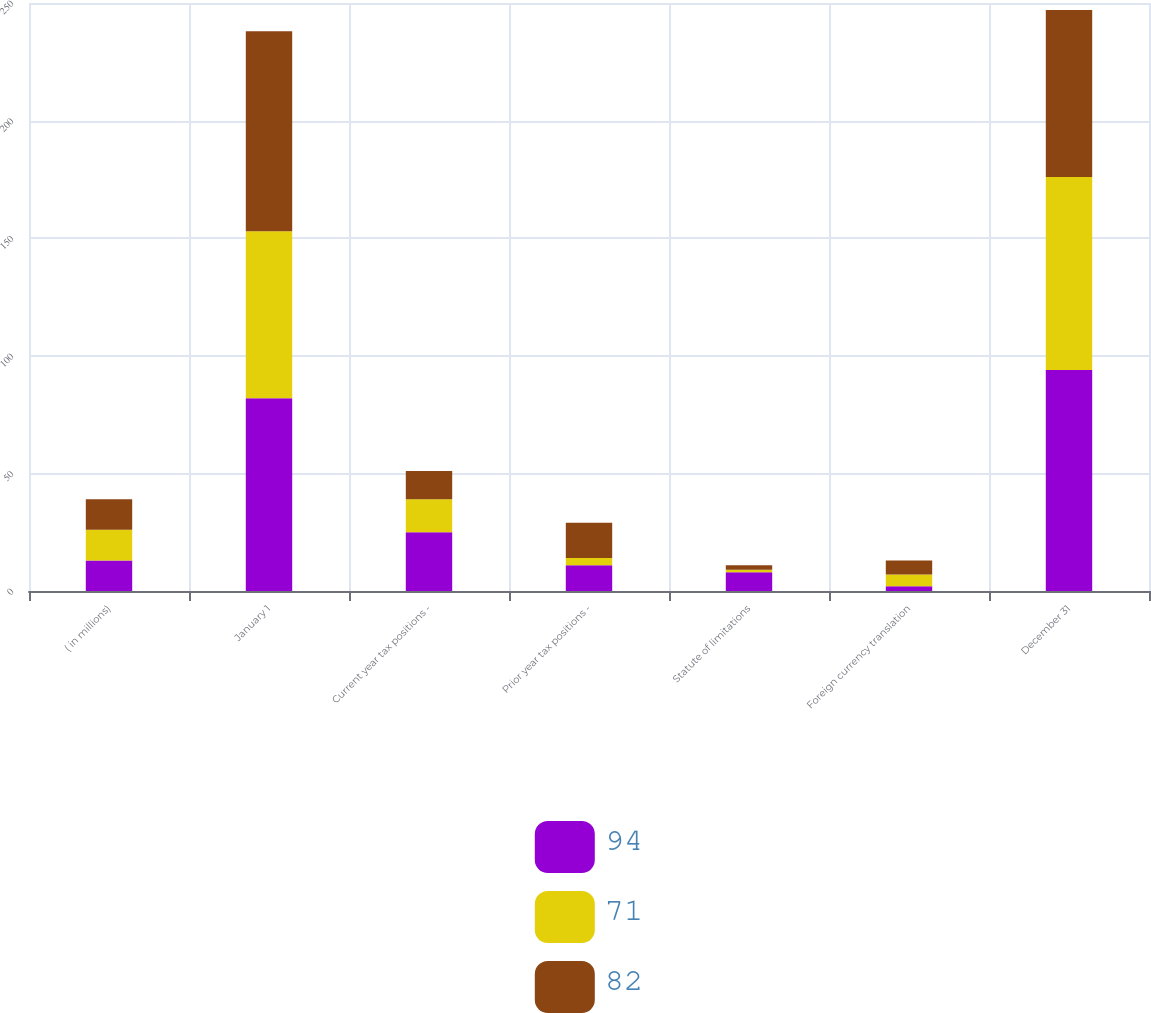<chart> <loc_0><loc_0><loc_500><loc_500><stacked_bar_chart><ecel><fcel>( in millions)<fcel>January 1<fcel>Current year tax positions -<fcel>Prior year tax positions -<fcel>Statute of limitations<fcel>Foreign currency translation<fcel>December 31<nl><fcel>94<fcel>13<fcel>82<fcel>25<fcel>11<fcel>8<fcel>2<fcel>94<nl><fcel>71<fcel>13<fcel>71<fcel>14<fcel>3<fcel>1<fcel>5<fcel>82<nl><fcel>82<fcel>13<fcel>85<fcel>12<fcel>15<fcel>2<fcel>6<fcel>71<nl></chart> 